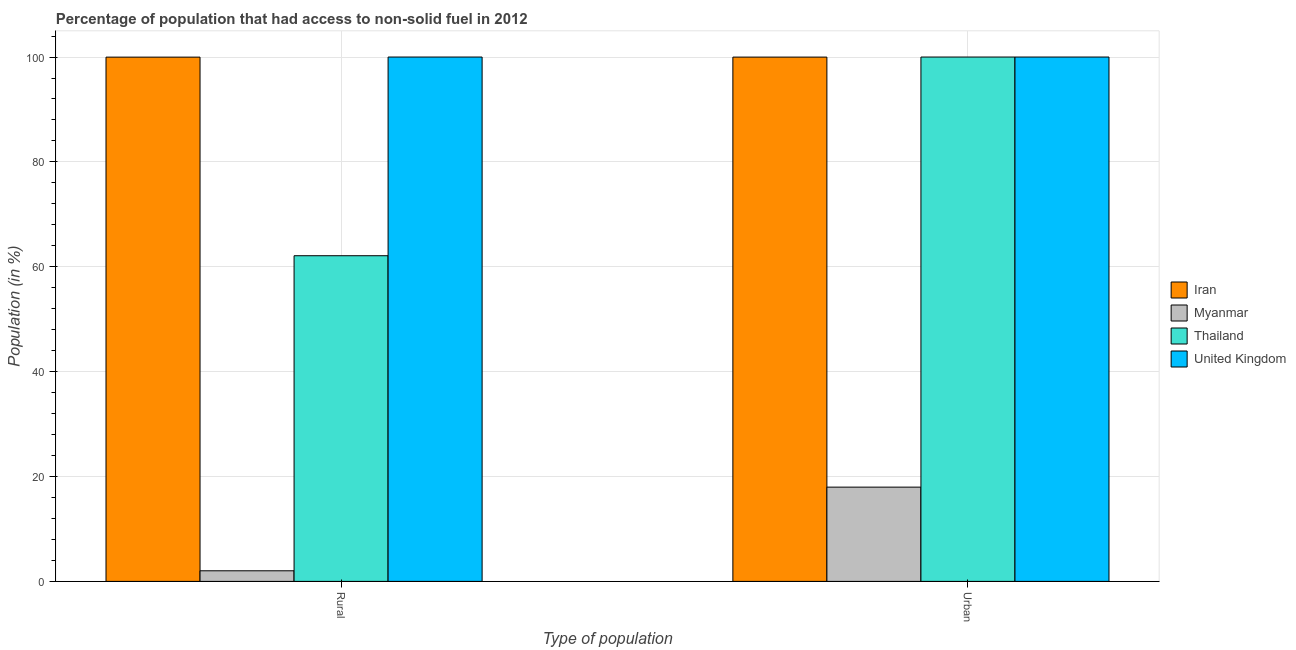How many different coloured bars are there?
Provide a succinct answer. 4. Are the number of bars per tick equal to the number of legend labels?
Your response must be concise. Yes. Are the number of bars on each tick of the X-axis equal?
Your response must be concise. Yes. How many bars are there on the 2nd tick from the left?
Your response must be concise. 4. What is the label of the 2nd group of bars from the left?
Make the answer very short. Urban. What is the rural population in Iran?
Ensure brevity in your answer.  99.98. Across all countries, what is the minimum urban population?
Give a very brief answer. 17.98. In which country was the rural population maximum?
Your answer should be compact. United Kingdom. In which country was the rural population minimum?
Your answer should be very brief. Myanmar. What is the total urban population in the graph?
Your response must be concise. 317.96. What is the difference between the urban population in Myanmar and that in United Kingdom?
Your answer should be compact. -82.02. What is the difference between the urban population in Myanmar and the rural population in Iran?
Your answer should be compact. -82.01. What is the average urban population per country?
Ensure brevity in your answer.  79.49. What is the difference between the urban population and rural population in Iran?
Make the answer very short. 0. In how many countries, is the urban population greater than the average urban population taken over all countries?
Offer a terse response. 3. What does the 4th bar from the left in Urban represents?
Your response must be concise. United Kingdom. What does the 4th bar from the right in Urban represents?
Provide a succinct answer. Iran. Are all the bars in the graph horizontal?
Your response must be concise. No. How many countries are there in the graph?
Your response must be concise. 4. What is the difference between two consecutive major ticks on the Y-axis?
Your answer should be compact. 20. Are the values on the major ticks of Y-axis written in scientific E-notation?
Provide a short and direct response. No. Does the graph contain any zero values?
Ensure brevity in your answer.  No. How many legend labels are there?
Offer a very short reply. 4. What is the title of the graph?
Offer a very short reply. Percentage of population that had access to non-solid fuel in 2012. Does "Guinea" appear as one of the legend labels in the graph?
Your response must be concise. No. What is the label or title of the X-axis?
Provide a succinct answer. Type of population. What is the label or title of the Y-axis?
Make the answer very short. Population (in %). What is the Population (in %) of Iran in Rural?
Ensure brevity in your answer.  99.98. What is the Population (in %) of Myanmar in Rural?
Your answer should be very brief. 2.02. What is the Population (in %) of Thailand in Rural?
Offer a terse response. 62.11. What is the Population (in %) of Iran in Urban?
Give a very brief answer. 99.99. What is the Population (in %) in Myanmar in Urban?
Ensure brevity in your answer.  17.98. Across all Type of population, what is the maximum Population (in %) in Iran?
Ensure brevity in your answer.  99.99. Across all Type of population, what is the maximum Population (in %) of Myanmar?
Provide a succinct answer. 17.98. Across all Type of population, what is the maximum Population (in %) in Thailand?
Make the answer very short. 100. Across all Type of population, what is the maximum Population (in %) of United Kingdom?
Offer a terse response. 100. Across all Type of population, what is the minimum Population (in %) in Iran?
Your answer should be very brief. 99.98. Across all Type of population, what is the minimum Population (in %) of Myanmar?
Provide a short and direct response. 2.02. Across all Type of population, what is the minimum Population (in %) in Thailand?
Offer a very short reply. 62.11. What is the total Population (in %) of Iran in the graph?
Provide a short and direct response. 199.97. What is the total Population (in %) of Myanmar in the graph?
Provide a succinct answer. 20. What is the total Population (in %) of Thailand in the graph?
Your answer should be compact. 162.11. What is the total Population (in %) of United Kingdom in the graph?
Offer a very short reply. 200. What is the difference between the Population (in %) in Iran in Rural and that in Urban?
Make the answer very short. -0. What is the difference between the Population (in %) in Myanmar in Rural and that in Urban?
Provide a succinct answer. -15.95. What is the difference between the Population (in %) of Thailand in Rural and that in Urban?
Offer a very short reply. -37.89. What is the difference between the Population (in %) in United Kingdom in Rural and that in Urban?
Give a very brief answer. 0. What is the difference between the Population (in %) in Iran in Rural and the Population (in %) in Myanmar in Urban?
Provide a short and direct response. 82.01. What is the difference between the Population (in %) of Iran in Rural and the Population (in %) of Thailand in Urban?
Your response must be concise. -0.02. What is the difference between the Population (in %) of Iran in Rural and the Population (in %) of United Kingdom in Urban?
Give a very brief answer. -0.02. What is the difference between the Population (in %) of Myanmar in Rural and the Population (in %) of Thailand in Urban?
Offer a very short reply. -97.98. What is the difference between the Population (in %) of Myanmar in Rural and the Population (in %) of United Kingdom in Urban?
Keep it short and to the point. -97.98. What is the difference between the Population (in %) of Thailand in Rural and the Population (in %) of United Kingdom in Urban?
Your response must be concise. -37.89. What is the average Population (in %) of Iran per Type of population?
Provide a short and direct response. 99.99. What is the average Population (in %) in Myanmar per Type of population?
Provide a short and direct response. 10. What is the average Population (in %) of Thailand per Type of population?
Your answer should be compact. 81.05. What is the difference between the Population (in %) in Iran and Population (in %) in Myanmar in Rural?
Provide a short and direct response. 97.96. What is the difference between the Population (in %) in Iran and Population (in %) in Thailand in Rural?
Keep it short and to the point. 37.88. What is the difference between the Population (in %) in Iran and Population (in %) in United Kingdom in Rural?
Offer a very short reply. -0.02. What is the difference between the Population (in %) in Myanmar and Population (in %) in Thailand in Rural?
Offer a very short reply. -60.09. What is the difference between the Population (in %) in Myanmar and Population (in %) in United Kingdom in Rural?
Your response must be concise. -97.98. What is the difference between the Population (in %) of Thailand and Population (in %) of United Kingdom in Rural?
Offer a very short reply. -37.89. What is the difference between the Population (in %) in Iran and Population (in %) in Myanmar in Urban?
Provide a short and direct response. 82.01. What is the difference between the Population (in %) of Iran and Population (in %) of Thailand in Urban?
Offer a terse response. -0.01. What is the difference between the Population (in %) in Iran and Population (in %) in United Kingdom in Urban?
Your response must be concise. -0.01. What is the difference between the Population (in %) in Myanmar and Population (in %) in Thailand in Urban?
Give a very brief answer. -82.02. What is the difference between the Population (in %) in Myanmar and Population (in %) in United Kingdom in Urban?
Your response must be concise. -82.02. What is the ratio of the Population (in %) of Myanmar in Rural to that in Urban?
Provide a succinct answer. 0.11. What is the ratio of the Population (in %) of Thailand in Rural to that in Urban?
Keep it short and to the point. 0.62. What is the difference between the highest and the second highest Population (in %) of Iran?
Offer a very short reply. 0. What is the difference between the highest and the second highest Population (in %) in Myanmar?
Offer a terse response. 15.95. What is the difference between the highest and the second highest Population (in %) in Thailand?
Make the answer very short. 37.89. What is the difference between the highest and the lowest Population (in %) in Iran?
Your answer should be very brief. 0. What is the difference between the highest and the lowest Population (in %) of Myanmar?
Offer a terse response. 15.95. What is the difference between the highest and the lowest Population (in %) in Thailand?
Offer a terse response. 37.89. What is the difference between the highest and the lowest Population (in %) of United Kingdom?
Provide a succinct answer. 0. 